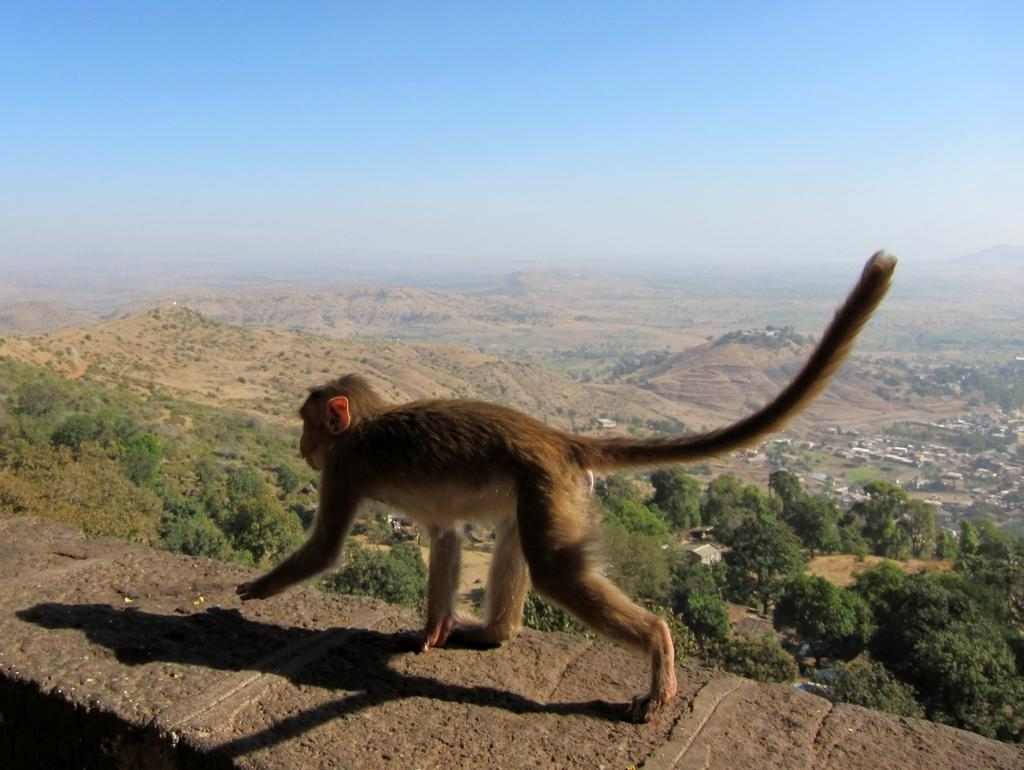What animal is present in the image? There is a monkey in the image. What is the monkey doing in the image? The monkey is walking on a rock surface. What can be seen in the background of the image? There are trees and mountains in the background of the image. What type of beam is holding up the structure in the image? There is no beam or structure present in the image; it features a monkey walking on a rock surface with trees and mountains in the background. 